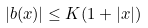Convert formula to latex. <formula><loc_0><loc_0><loc_500><loc_500>| b ( x ) | \leq K ( 1 + | x | )</formula> 